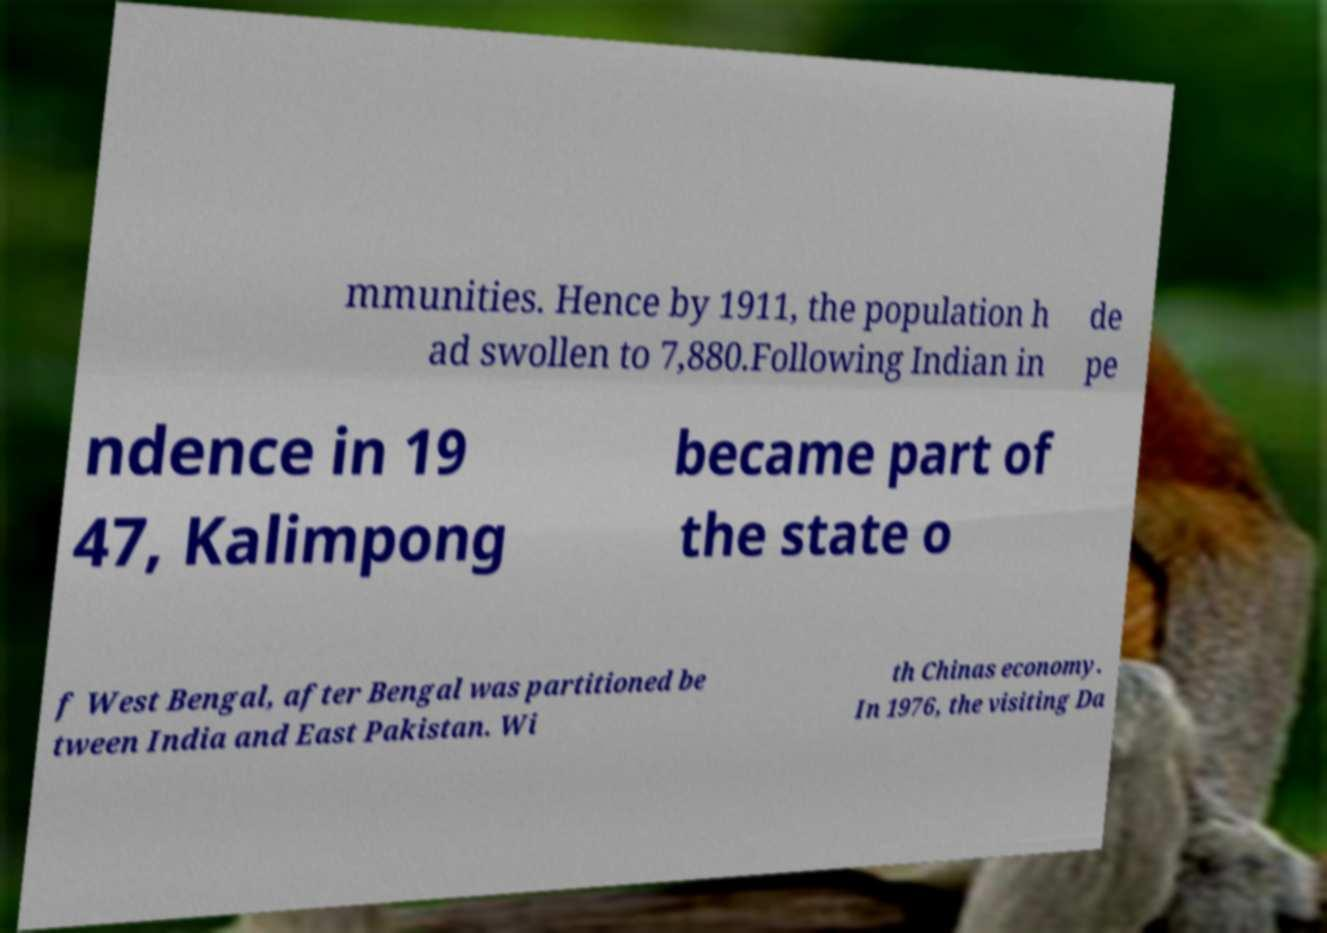Could you extract and type out the text from this image? mmunities. Hence by 1911, the population h ad swollen to 7,880.Following Indian in de pe ndence in 19 47, Kalimpong became part of the state o f West Bengal, after Bengal was partitioned be tween India and East Pakistan. Wi th Chinas economy. In 1976, the visiting Da 